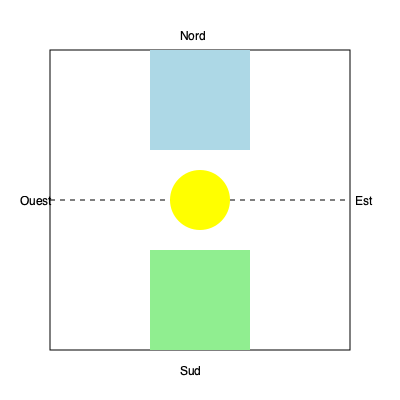Based on your knowledge of medieval jousting tournaments, reconstruct the layout of a typical French jousting field from the given fragments. Which element is missing from the center of the field? To reconstruct the layout of a typical French medieval jousting field, we need to consider the following steps:

1. Orientation: The field is typically oriented north-south, with the nobles' viewing stands usually placed on the western side.

2. Main elements:
   a) The tilt (la lice): A wooden barrier running down the center of the field, separating the two lanes for the jousting knights. This is represented by the dashed line in the middle of the field.
   b) Starting positions: Two areas at opposite ends of the field where knights begin their charge. These are shown as colored rectangles at the north and south ends.
   c) Viewing stands: Areas for spectators, typically on the western side (not shown in this diagram).

3. Central element: In many French jousting tournaments, especially those of the 15th and 16th centuries, a central post or column was often placed at the middle of the tilt. This post, known as the "quintain" or "pel," served multiple purposes:
   - It marked the midpoint of the jousting run.
   - It could be used for practice, with a shield or target attached.
   - It sometimes held heraldic devices or banners.

4. Missing element: In the given diagram, we can see the tilt (dashed line) and the starting positions (colored rectangles), but the central element is represented by a circle. This circle likely represents the location where the quintain or central post should be placed.

Therefore, the missing element from the center of the field is the quintain or central post.
Answer: Quintain (or central post) 